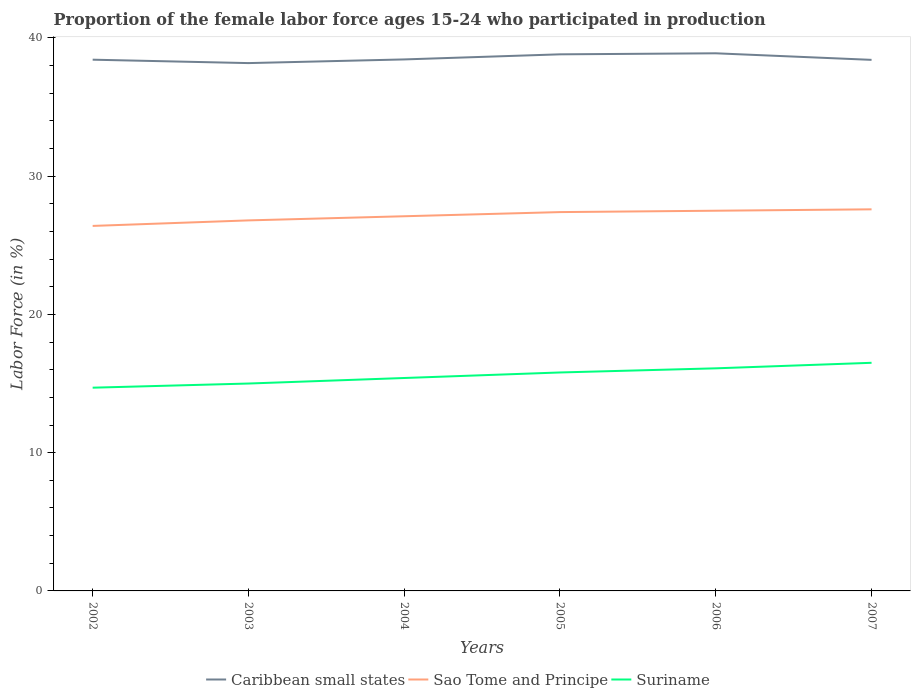How many different coloured lines are there?
Provide a succinct answer. 3. Is the number of lines equal to the number of legend labels?
Offer a very short reply. Yes. Across all years, what is the maximum proportion of the female labor force who participated in production in Sao Tome and Principe?
Keep it short and to the point. 26.4. What is the total proportion of the female labor force who participated in production in Sao Tome and Principe in the graph?
Provide a short and direct response. -0.2. What is the difference between the highest and the second highest proportion of the female labor force who participated in production in Suriname?
Your response must be concise. 1.8. What is the difference between the highest and the lowest proportion of the female labor force who participated in production in Sao Tome and Principe?
Offer a very short reply. 3. Is the proportion of the female labor force who participated in production in Suriname strictly greater than the proportion of the female labor force who participated in production in Sao Tome and Principe over the years?
Provide a short and direct response. Yes. How many lines are there?
Your answer should be compact. 3. What is the title of the graph?
Provide a succinct answer. Proportion of the female labor force ages 15-24 who participated in production. What is the label or title of the X-axis?
Offer a very short reply. Years. What is the Labor Force (in %) of Caribbean small states in 2002?
Your response must be concise. 38.42. What is the Labor Force (in %) of Sao Tome and Principe in 2002?
Your response must be concise. 26.4. What is the Labor Force (in %) of Suriname in 2002?
Your answer should be very brief. 14.7. What is the Labor Force (in %) in Caribbean small states in 2003?
Offer a terse response. 38.18. What is the Labor Force (in %) of Sao Tome and Principe in 2003?
Your answer should be very brief. 26.8. What is the Labor Force (in %) in Suriname in 2003?
Ensure brevity in your answer.  15. What is the Labor Force (in %) of Caribbean small states in 2004?
Ensure brevity in your answer.  38.44. What is the Labor Force (in %) in Sao Tome and Principe in 2004?
Offer a very short reply. 27.1. What is the Labor Force (in %) in Suriname in 2004?
Your answer should be very brief. 15.4. What is the Labor Force (in %) in Caribbean small states in 2005?
Provide a short and direct response. 38.81. What is the Labor Force (in %) in Sao Tome and Principe in 2005?
Your response must be concise. 27.4. What is the Labor Force (in %) in Suriname in 2005?
Offer a very short reply. 15.8. What is the Labor Force (in %) of Caribbean small states in 2006?
Provide a short and direct response. 38.89. What is the Labor Force (in %) in Suriname in 2006?
Your answer should be very brief. 16.1. What is the Labor Force (in %) in Caribbean small states in 2007?
Your answer should be compact. 38.41. What is the Labor Force (in %) in Sao Tome and Principe in 2007?
Your answer should be very brief. 27.6. Across all years, what is the maximum Labor Force (in %) of Caribbean small states?
Give a very brief answer. 38.89. Across all years, what is the maximum Labor Force (in %) in Sao Tome and Principe?
Give a very brief answer. 27.6. Across all years, what is the minimum Labor Force (in %) in Caribbean small states?
Your response must be concise. 38.18. Across all years, what is the minimum Labor Force (in %) of Sao Tome and Principe?
Give a very brief answer. 26.4. Across all years, what is the minimum Labor Force (in %) in Suriname?
Keep it short and to the point. 14.7. What is the total Labor Force (in %) of Caribbean small states in the graph?
Your response must be concise. 231.15. What is the total Labor Force (in %) in Sao Tome and Principe in the graph?
Your answer should be very brief. 162.8. What is the total Labor Force (in %) of Suriname in the graph?
Keep it short and to the point. 93.5. What is the difference between the Labor Force (in %) in Caribbean small states in 2002 and that in 2003?
Your response must be concise. 0.25. What is the difference between the Labor Force (in %) in Sao Tome and Principe in 2002 and that in 2003?
Give a very brief answer. -0.4. What is the difference between the Labor Force (in %) of Suriname in 2002 and that in 2003?
Your answer should be compact. -0.3. What is the difference between the Labor Force (in %) of Caribbean small states in 2002 and that in 2004?
Your response must be concise. -0.02. What is the difference between the Labor Force (in %) in Suriname in 2002 and that in 2004?
Provide a short and direct response. -0.7. What is the difference between the Labor Force (in %) in Caribbean small states in 2002 and that in 2005?
Ensure brevity in your answer.  -0.39. What is the difference between the Labor Force (in %) of Sao Tome and Principe in 2002 and that in 2005?
Your response must be concise. -1. What is the difference between the Labor Force (in %) in Caribbean small states in 2002 and that in 2006?
Your response must be concise. -0.46. What is the difference between the Labor Force (in %) in Suriname in 2002 and that in 2006?
Provide a succinct answer. -1.4. What is the difference between the Labor Force (in %) of Caribbean small states in 2002 and that in 2007?
Provide a succinct answer. 0.01. What is the difference between the Labor Force (in %) in Suriname in 2002 and that in 2007?
Offer a very short reply. -1.8. What is the difference between the Labor Force (in %) in Caribbean small states in 2003 and that in 2004?
Provide a succinct answer. -0.27. What is the difference between the Labor Force (in %) in Suriname in 2003 and that in 2004?
Offer a terse response. -0.4. What is the difference between the Labor Force (in %) of Caribbean small states in 2003 and that in 2005?
Make the answer very short. -0.63. What is the difference between the Labor Force (in %) in Sao Tome and Principe in 2003 and that in 2005?
Ensure brevity in your answer.  -0.6. What is the difference between the Labor Force (in %) in Caribbean small states in 2003 and that in 2006?
Offer a very short reply. -0.71. What is the difference between the Labor Force (in %) of Caribbean small states in 2003 and that in 2007?
Your answer should be compact. -0.23. What is the difference between the Labor Force (in %) of Caribbean small states in 2004 and that in 2005?
Your answer should be very brief. -0.37. What is the difference between the Labor Force (in %) of Caribbean small states in 2004 and that in 2006?
Offer a very short reply. -0.44. What is the difference between the Labor Force (in %) of Sao Tome and Principe in 2004 and that in 2006?
Keep it short and to the point. -0.4. What is the difference between the Labor Force (in %) in Caribbean small states in 2004 and that in 2007?
Ensure brevity in your answer.  0.03. What is the difference between the Labor Force (in %) in Sao Tome and Principe in 2004 and that in 2007?
Make the answer very short. -0.5. What is the difference between the Labor Force (in %) in Suriname in 2004 and that in 2007?
Your response must be concise. -1.1. What is the difference between the Labor Force (in %) of Caribbean small states in 2005 and that in 2006?
Provide a succinct answer. -0.08. What is the difference between the Labor Force (in %) in Sao Tome and Principe in 2005 and that in 2006?
Provide a short and direct response. -0.1. What is the difference between the Labor Force (in %) in Caribbean small states in 2005 and that in 2007?
Make the answer very short. 0.4. What is the difference between the Labor Force (in %) of Caribbean small states in 2006 and that in 2007?
Offer a very short reply. 0.48. What is the difference between the Labor Force (in %) in Suriname in 2006 and that in 2007?
Make the answer very short. -0.4. What is the difference between the Labor Force (in %) in Caribbean small states in 2002 and the Labor Force (in %) in Sao Tome and Principe in 2003?
Make the answer very short. 11.62. What is the difference between the Labor Force (in %) in Caribbean small states in 2002 and the Labor Force (in %) in Suriname in 2003?
Your response must be concise. 23.42. What is the difference between the Labor Force (in %) in Caribbean small states in 2002 and the Labor Force (in %) in Sao Tome and Principe in 2004?
Your answer should be compact. 11.32. What is the difference between the Labor Force (in %) of Caribbean small states in 2002 and the Labor Force (in %) of Suriname in 2004?
Your answer should be very brief. 23.02. What is the difference between the Labor Force (in %) in Caribbean small states in 2002 and the Labor Force (in %) in Sao Tome and Principe in 2005?
Provide a short and direct response. 11.02. What is the difference between the Labor Force (in %) of Caribbean small states in 2002 and the Labor Force (in %) of Suriname in 2005?
Provide a short and direct response. 22.62. What is the difference between the Labor Force (in %) in Sao Tome and Principe in 2002 and the Labor Force (in %) in Suriname in 2005?
Make the answer very short. 10.6. What is the difference between the Labor Force (in %) in Caribbean small states in 2002 and the Labor Force (in %) in Sao Tome and Principe in 2006?
Ensure brevity in your answer.  10.92. What is the difference between the Labor Force (in %) of Caribbean small states in 2002 and the Labor Force (in %) of Suriname in 2006?
Make the answer very short. 22.32. What is the difference between the Labor Force (in %) in Caribbean small states in 2002 and the Labor Force (in %) in Sao Tome and Principe in 2007?
Your response must be concise. 10.82. What is the difference between the Labor Force (in %) in Caribbean small states in 2002 and the Labor Force (in %) in Suriname in 2007?
Provide a succinct answer. 21.92. What is the difference between the Labor Force (in %) of Sao Tome and Principe in 2002 and the Labor Force (in %) of Suriname in 2007?
Your response must be concise. 9.9. What is the difference between the Labor Force (in %) in Caribbean small states in 2003 and the Labor Force (in %) in Sao Tome and Principe in 2004?
Your answer should be compact. 11.08. What is the difference between the Labor Force (in %) of Caribbean small states in 2003 and the Labor Force (in %) of Suriname in 2004?
Your answer should be very brief. 22.78. What is the difference between the Labor Force (in %) of Caribbean small states in 2003 and the Labor Force (in %) of Sao Tome and Principe in 2005?
Your answer should be very brief. 10.78. What is the difference between the Labor Force (in %) of Caribbean small states in 2003 and the Labor Force (in %) of Suriname in 2005?
Ensure brevity in your answer.  22.38. What is the difference between the Labor Force (in %) of Sao Tome and Principe in 2003 and the Labor Force (in %) of Suriname in 2005?
Offer a very short reply. 11. What is the difference between the Labor Force (in %) of Caribbean small states in 2003 and the Labor Force (in %) of Sao Tome and Principe in 2006?
Your answer should be compact. 10.68. What is the difference between the Labor Force (in %) of Caribbean small states in 2003 and the Labor Force (in %) of Suriname in 2006?
Ensure brevity in your answer.  22.08. What is the difference between the Labor Force (in %) in Caribbean small states in 2003 and the Labor Force (in %) in Sao Tome and Principe in 2007?
Make the answer very short. 10.58. What is the difference between the Labor Force (in %) in Caribbean small states in 2003 and the Labor Force (in %) in Suriname in 2007?
Provide a short and direct response. 21.68. What is the difference between the Labor Force (in %) of Sao Tome and Principe in 2003 and the Labor Force (in %) of Suriname in 2007?
Your response must be concise. 10.3. What is the difference between the Labor Force (in %) of Caribbean small states in 2004 and the Labor Force (in %) of Sao Tome and Principe in 2005?
Your response must be concise. 11.04. What is the difference between the Labor Force (in %) in Caribbean small states in 2004 and the Labor Force (in %) in Suriname in 2005?
Offer a very short reply. 22.64. What is the difference between the Labor Force (in %) in Sao Tome and Principe in 2004 and the Labor Force (in %) in Suriname in 2005?
Make the answer very short. 11.3. What is the difference between the Labor Force (in %) of Caribbean small states in 2004 and the Labor Force (in %) of Sao Tome and Principe in 2006?
Make the answer very short. 10.94. What is the difference between the Labor Force (in %) of Caribbean small states in 2004 and the Labor Force (in %) of Suriname in 2006?
Keep it short and to the point. 22.34. What is the difference between the Labor Force (in %) in Sao Tome and Principe in 2004 and the Labor Force (in %) in Suriname in 2006?
Offer a terse response. 11. What is the difference between the Labor Force (in %) in Caribbean small states in 2004 and the Labor Force (in %) in Sao Tome and Principe in 2007?
Provide a succinct answer. 10.84. What is the difference between the Labor Force (in %) in Caribbean small states in 2004 and the Labor Force (in %) in Suriname in 2007?
Make the answer very short. 21.94. What is the difference between the Labor Force (in %) in Caribbean small states in 2005 and the Labor Force (in %) in Sao Tome and Principe in 2006?
Ensure brevity in your answer.  11.31. What is the difference between the Labor Force (in %) in Caribbean small states in 2005 and the Labor Force (in %) in Suriname in 2006?
Give a very brief answer. 22.71. What is the difference between the Labor Force (in %) in Caribbean small states in 2005 and the Labor Force (in %) in Sao Tome and Principe in 2007?
Provide a short and direct response. 11.21. What is the difference between the Labor Force (in %) of Caribbean small states in 2005 and the Labor Force (in %) of Suriname in 2007?
Provide a succinct answer. 22.31. What is the difference between the Labor Force (in %) in Caribbean small states in 2006 and the Labor Force (in %) in Sao Tome and Principe in 2007?
Provide a succinct answer. 11.29. What is the difference between the Labor Force (in %) of Caribbean small states in 2006 and the Labor Force (in %) of Suriname in 2007?
Your response must be concise. 22.39. What is the difference between the Labor Force (in %) of Sao Tome and Principe in 2006 and the Labor Force (in %) of Suriname in 2007?
Offer a very short reply. 11. What is the average Labor Force (in %) of Caribbean small states per year?
Offer a very short reply. 38.52. What is the average Labor Force (in %) of Sao Tome and Principe per year?
Ensure brevity in your answer.  27.13. What is the average Labor Force (in %) in Suriname per year?
Offer a terse response. 15.58. In the year 2002, what is the difference between the Labor Force (in %) in Caribbean small states and Labor Force (in %) in Sao Tome and Principe?
Your answer should be compact. 12.02. In the year 2002, what is the difference between the Labor Force (in %) in Caribbean small states and Labor Force (in %) in Suriname?
Make the answer very short. 23.72. In the year 2003, what is the difference between the Labor Force (in %) in Caribbean small states and Labor Force (in %) in Sao Tome and Principe?
Make the answer very short. 11.38. In the year 2003, what is the difference between the Labor Force (in %) of Caribbean small states and Labor Force (in %) of Suriname?
Ensure brevity in your answer.  23.18. In the year 2004, what is the difference between the Labor Force (in %) of Caribbean small states and Labor Force (in %) of Sao Tome and Principe?
Provide a succinct answer. 11.34. In the year 2004, what is the difference between the Labor Force (in %) in Caribbean small states and Labor Force (in %) in Suriname?
Your answer should be compact. 23.04. In the year 2004, what is the difference between the Labor Force (in %) of Sao Tome and Principe and Labor Force (in %) of Suriname?
Keep it short and to the point. 11.7. In the year 2005, what is the difference between the Labor Force (in %) of Caribbean small states and Labor Force (in %) of Sao Tome and Principe?
Keep it short and to the point. 11.41. In the year 2005, what is the difference between the Labor Force (in %) of Caribbean small states and Labor Force (in %) of Suriname?
Keep it short and to the point. 23.01. In the year 2006, what is the difference between the Labor Force (in %) in Caribbean small states and Labor Force (in %) in Sao Tome and Principe?
Your answer should be compact. 11.39. In the year 2006, what is the difference between the Labor Force (in %) of Caribbean small states and Labor Force (in %) of Suriname?
Offer a very short reply. 22.79. In the year 2006, what is the difference between the Labor Force (in %) of Sao Tome and Principe and Labor Force (in %) of Suriname?
Your answer should be very brief. 11.4. In the year 2007, what is the difference between the Labor Force (in %) in Caribbean small states and Labor Force (in %) in Sao Tome and Principe?
Offer a terse response. 10.81. In the year 2007, what is the difference between the Labor Force (in %) in Caribbean small states and Labor Force (in %) in Suriname?
Offer a terse response. 21.91. In the year 2007, what is the difference between the Labor Force (in %) in Sao Tome and Principe and Labor Force (in %) in Suriname?
Provide a succinct answer. 11.1. What is the ratio of the Labor Force (in %) in Caribbean small states in 2002 to that in 2003?
Provide a succinct answer. 1.01. What is the ratio of the Labor Force (in %) in Sao Tome and Principe in 2002 to that in 2003?
Keep it short and to the point. 0.99. What is the ratio of the Labor Force (in %) in Suriname in 2002 to that in 2003?
Your answer should be very brief. 0.98. What is the ratio of the Labor Force (in %) of Sao Tome and Principe in 2002 to that in 2004?
Your answer should be very brief. 0.97. What is the ratio of the Labor Force (in %) of Suriname in 2002 to that in 2004?
Give a very brief answer. 0.95. What is the ratio of the Labor Force (in %) in Caribbean small states in 2002 to that in 2005?
Offer a terse response. 0.99. What is the ratio of the Labor Force (in %) in Sao Tome and Principe in 2002 to that in 2005?
Your answer should be compact. 0.96. What is the ratio of the Labor Force (in %) in Suriname in 2002 to that in 2005?
Your answer should be very brief. 0.93. What is the ratio of the Labor Force (in %) of Caribbean small states in 2002 to that in 2007?
Keep it short and to the point. 1. What is the ratio of the Labor Force (in %) of Sao Tome and Principe in 2002 to that in 2007?
Keep it short and to the point. 0.96. What is the ratio of the Labor Force (in %) of Suriname in 2002 to that in 2007?
Offer a very short reply. 0.89. What is the ratio of the Labor Force (in %) of Caribbean small states in 2003 to that in 2004?
Keep it short and to the point. 0.99. What is the ratio of the Labor Force (in %) in Sao Tome and Principe in 2003 to that in 2004?
Your answer should be very brief. 0.99. What is the ratio of the Labor Force (in %) of Suriname in 2003 to that in 2004?
Your answer should be very brief. 0.97. What is the ratio of the Labor Force (in %) in Caribbean small states in 2003 to that in 2005?
Provide a succinct answer. 0.98. What is the ratio of the Labor Force (in %) of Sao Tome and Principe in 2003 to that in 2005?
Keep it short and to the point. 0.98. What is the ratio of the Labor Force (in %) of Suriname in 2003 to that in 2005?
Keep it short and to the point. 0.95. What is the ratio of the Labor Force (in %) in Caribbean small states in 2003 to that in 2006?
Your response must be concise. 0.98. What is the ratio of the Labor Force (in %) in Sao Tome and Principe in 2003 to that in 2006?
Ensure brevity in your answer.  0.97. What is the ratio of the Labor Force (in %) in Suriname in 2003 to that in 2006?
Your answer should be compact. 0.93. What is the ratio of the Labor Force (in %) of Caribbean small states in 2004 to that in 2005?
Your response must be concise. 0.99. What is the ratio of the Labor Force (in %) of Sao Tome and Principe in 2004 to that in 2005?
Ensure brevity in your answer.  0.99. What is the ratio of the Labor Force (in %) in Suriname in 2004 to that in 2005?
Offer a very short reply. 0.97. What is the ratio of the Labor Force (in %) in Caribbean small states in 2004 to that in 2006?
Keep it short and to the point. 0.99. What is the ratio of the Labor Force (in %) in Sao Tome and Principe in 2004 to that in 2006?
Your answer should be compact. 0.99. What is the ratio of the Labor Force (in %) in Suriname in 2004 to that in 2006?
Your answer should be compact. 0.96. What is the ratio of the Labor Force (in %) of Caribbean small states in 2004 to that in 2007?
Ensure brevity in your answer.  1. What is the ratio of the Labor Force (in %) in Sao Tome and Principe in 2004 to that in 2007?
Keep it short and to the point. 0.98. What is the ratio of the Labor Force (in %) of Suriname in 2004 to that in 2007?
Your response must be concise. 0.93. What is the ratio of the Labor Force (in %) of Caribbean small states in 2005 to that in 2006?
Offer a very short reply. 1. What is the ratio of the Labor Force (in %) in Sao Tome and Principe in 2005 to that in 2006?
Provide a succinct answer. 1. What is the ratio of the Labor Force (in %) in Suriname in 2005 to that in 2006?
Your answer should be compact. 0.98. What is the ratio of the Labor Force (in %) of Caribbean small states in 2005 to that in 2007?
Give a very brief answer. 1.01. What is the ratio of the Labor Force (in %) in Sao Tome and Principe in 2005 to that in 2007?
Make the answer very short. 0.99. What is the ratio of the Labor Force (in %) in Suriname in 2005 to that in 2007?
Offer a very short reply. 0.96. What is the ratio of the Labor Force (in %) of Caribbean small states in 2006 to that in 2007?
Provide a short and direct response. 1.01. What is the ratio of the Labor Force (in %) in Sao Tome and Principe in 2006 to that in 2007?
Ensure brevity in your answer.  1. What is the ratio of the Labor Force (in %) in Suriname in 2006 to that in 2007?
Offer a very short reply. 0.98. What is the difference between the highest and the second highest Labor Force (in %) in Caribbean small states?
Your answer should be very brief. 0.08. What is the difference between the highest and the second highest Labor Force (in %) in Sao Tome and Principe?
Provide a succinct answer. 0.1. What is the difference between the highest and the lowest Labor Force (in %) of Caribbean small states?
Your answer should be very brief. 0.71. 